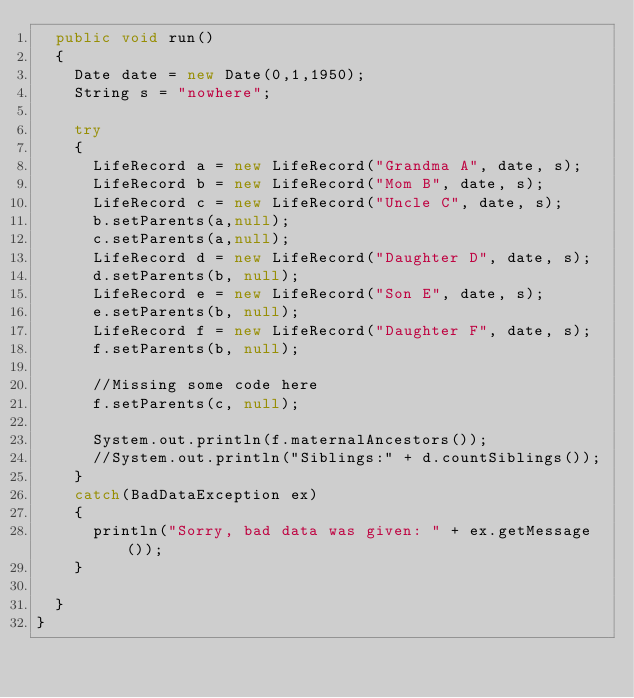<code> <loc_0><loc_0><loc_500><loc_500><_Java_>	public void run()
	{
		Date date = new Date(0,1,1950);
		String s = "nowhere";

		try
		{
			LifeRecord a = new LifeRecord("Grandma A", date, s);
			LifeRecord b = new LifeRecord("Mom B", date, s);
			LifeRecord c = new LifeRecord("Uncle C", date, s);
			b.setParents(a,null);
			c.setParents(a,null);
			LifeRecord d = new LifeRecord("Daughter D", date, s);
			d.setParents(b, null);
			LifeRecord e = new LifeRecord("Son E", date, s);
			e.setParents(b, null);
			LifeRecord f = new LifeRecord("Daughter F", date, s);
			f.setParents(b, null);

			//Missing some code here
			f.setParents(c, null);

			System.out.println(f.maternalAncestors());
			//System.out.println("Siblings:" + d.countSiblings());
		}
		catch(BadDataException ex)
		{
			println("Sorry, bad data was given: " + ex.getMessage());
		}
		
	}
}
</code> 